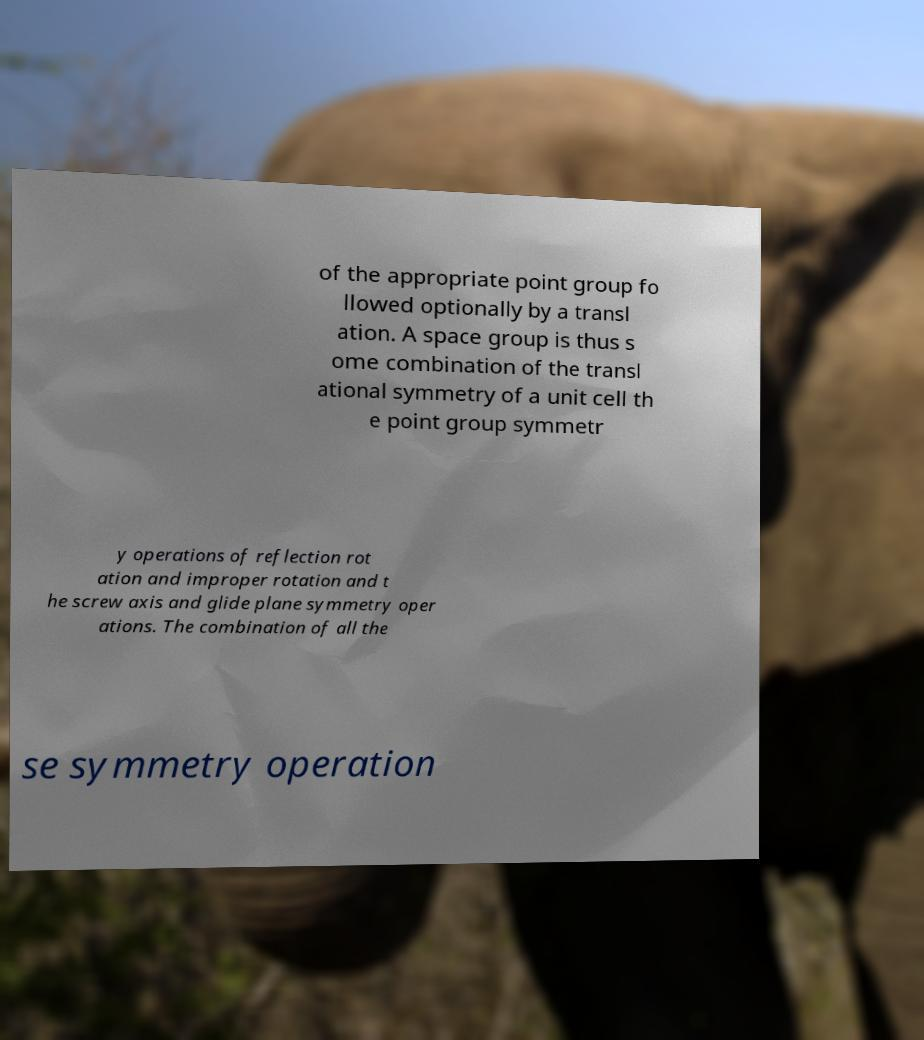I need the written content from this picture converted into text. Can you do that? of the appropriate point group fo llowed optionally by a transl ation. A space group is thus s ome combination of the transl ational symmetry of a unit cell th e point group symmetr y operations of reflection rot ation and improper rotation and t he screw axis and glide plane symmetry oper ations. The combination of all the se symmetry operation 